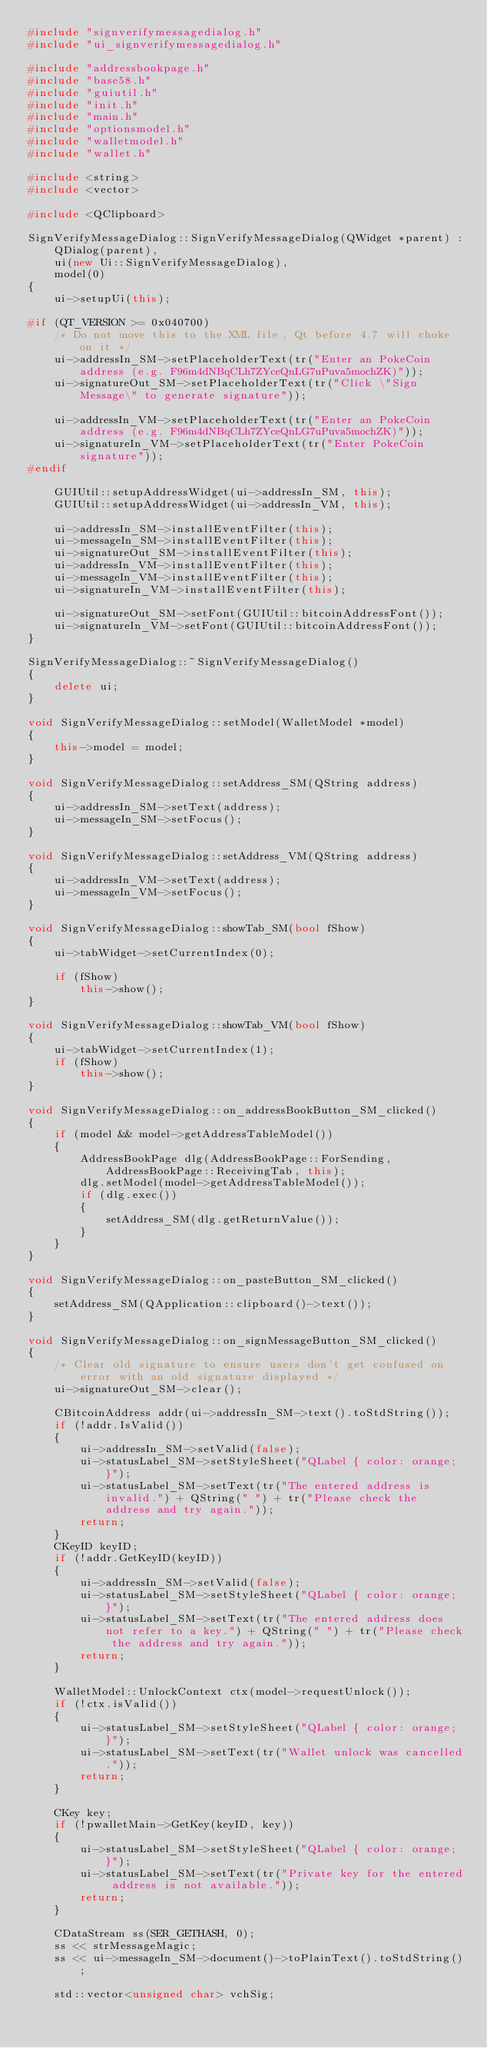<code> <loc_0><loc_0><loc_500><loc_500><_C++_>#include "signverifymessagedialog.h"
#include "ui_signverifymessagedialog.h"

#include "addressbookpage.h"
#include "base58.h"
#include "guiutil.h"
#include "init.h"
#include "main.h"
#include "optionsmodel.h"
#include "walletmodel.h"
#include "wallet.h"

#include <string>
#include <vector>

#include <QClipboard>

SignVerifyMessageDialog::SignVerifyMessageDialog(QWidget *parent) :
    QDialog(parent),
    ui(new Ui::SignVerifyMessageDialog),
    model(0)
{
    ui->setupUi(this);

#if (QT_VERSION >= 0x040700)
    /* Do not move this to the XML file, Qt before 4.7 will choke on it */
    ui->addressIn_SM->setPlaceholderText(tr("Enter an PokeCoin address (e.g. F96m4dNBqCLh7ZYceQnLG7uPuva5mochZK)"));
    ui->signatureOut_SM->setPlaceholderText(tr("Click \"Sign Message\" to generate signature"));

    ui->addressIn_VM->setPlaceholderText(tr("Enter an PokeCoin address (e.g. F96m4dNBqCLh7ZYceQnLG7uPuva5mochZK)"));
    ui->signatureIn_VM->setPlaceholderText(tr("Enter PokeCoin signature"));
#endif

    GUIUtil::setupAddressWidget(ui->addressIn_SM, this);
    GUIUtil::setupAddressWidget(ui->addressIn_VM, this);

    ui->addressIn_SM->installEventFilter(this);
    ui->messageIn_SM->installEventFilter(this);
    ui->signatureOut_SM->installEventFilter(this);
    ui->addressIn_VM->installEventFilter(this);
    ui->messageIn_VM->installEventFilter(this);
    ui->signatureIn_VM->installEventFilter(this);

    ui->signatureOut_SM->setFont(GUIUtil::bitcoinAddressFont());
    ui->signatureIn_VM->setFont(GUIUtil::bitcoinAddressFont());
}

SignVerifyMessageDialog::~SignVerifyMessageDialog()
{
    delete ui;
}

void SignVerifyMessageDialog::setModel(WalletModel *model)
{
    this->model = model;
}

void SignVerifyMessageDialog::setAddress_SM(QString address)
{
    ui->addressIn_SM->setText(address);
    ui->messageIn_SM->setFocus();
}

void SignVerifyMessageDialog::setAddress_VM(QString address)
{
    ui->addressIn_VM->setText(address);
    ui->messageIn_VM->setFocus();
}

void SignVerifyMessageDialog::showTab_SM(bool fShow)
{
    ui->tabWidget->setCurrentIndex(0);

    if (fShow)
        this->show();
}

void SignVerifyMessageDialog::showTab_VM(bool fShow)
{
    ui->tabWidget->setCurrentIndex(1);
    if (fShow)
        this->show();
}

void SignVerifyMessageDialog::on_addressBookButton_SM_clicked()
{
    if (model && model->getAddressTableModel())
    {
        AddressBookPage dlg(AddressBookPage::ForSending, AddressBookPage::ReceivingTab, this);
        dlg.setModel(model->getAddressTableModel());
        if (dlg.exec())
        {
            setAddress_SM(dlg.getReturnValue());
        }
    }
}

void SignVerifyMessageDialog::on_pasteButton_SM_clicked()
{
    setAddress_SM(QApplication::clipboard()->text());
}

void SignVerifyMessageDialog::on_signMessageButton_SM_clicked()
{
    /* Clear old signature to ensure users don't get confused on error with an old signature displayed */
    ui->signatureOut_SM->clear();

    CBitcoinAddress addr(ui->addressIn_SM->text().toStdString());
    if (!addr.IsValid())
    {
        ui->addressIn_SM->setValid(false);
        ui->statusLabel_SM->setStyleSheet("QLabel { color: orange; }");
        ui->statusLabel_SM->setText(tr("The entered address is invalid.") + QString(" ") + tr("Please check the address and try again."));
        return;
    }
    CKeyID keyID;
    if (!addr.GetKeyID(keyID))
    {
        ui->addressIn_SM->setValid(false);
        ui->statusLabel_SM->setStyleSheet("QLabel { color: orange; }");
        ui->statusLabel_SM->setText(tr("The entered address does not refer to a key.") + QString(" ") + tr("Please check the address and try again."));
        return;
    }

    WalletModel::UnlockContext ctx(model->requestUnlock());
    if (!ctx.isValid())
    {
        ui->statusLabel_SM->setStyleSheet("QLabel { color: orange; }");
        ui->statusLabel_SM->setText(tr("Wallet unlock was cancelled."));
        return;
    }

    CKey key;
    if (!pwalletMain->GetKey(keyID, key))
    {
        ui->statusLabel_SM->setStyleSheet("QLabel { color: orange; }");
        ui->statusLabel_SM->setText(tr("Private key for the entered address is not available."));
        return;
    }

    CDataStream ss(SER_GETHASH, 0);
    ss << strMessageMagic;
    ss << ui->messageIn_SM->document()->toPlainText().toStdString();

    std::vector<unsigned char> vchSig;</code> 